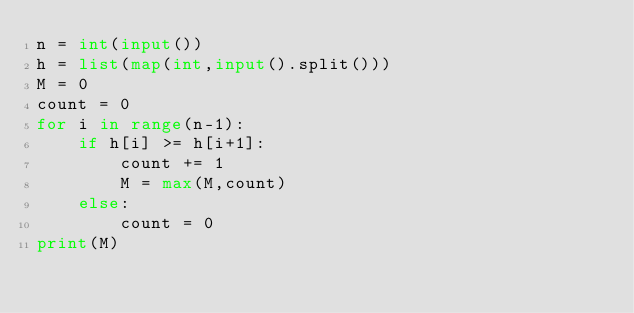<code> <loc_0><loc_0><loc_500><loc_500><_Python_>n = int(input())
h = list(map(int,input().split()))
M = 0
count = 0
for i in range(n-1):
    if h[i] >= h[i+1]:
        count += 1
        M = max(M,count)
    else:
        count = 0
print(M)
</code> 